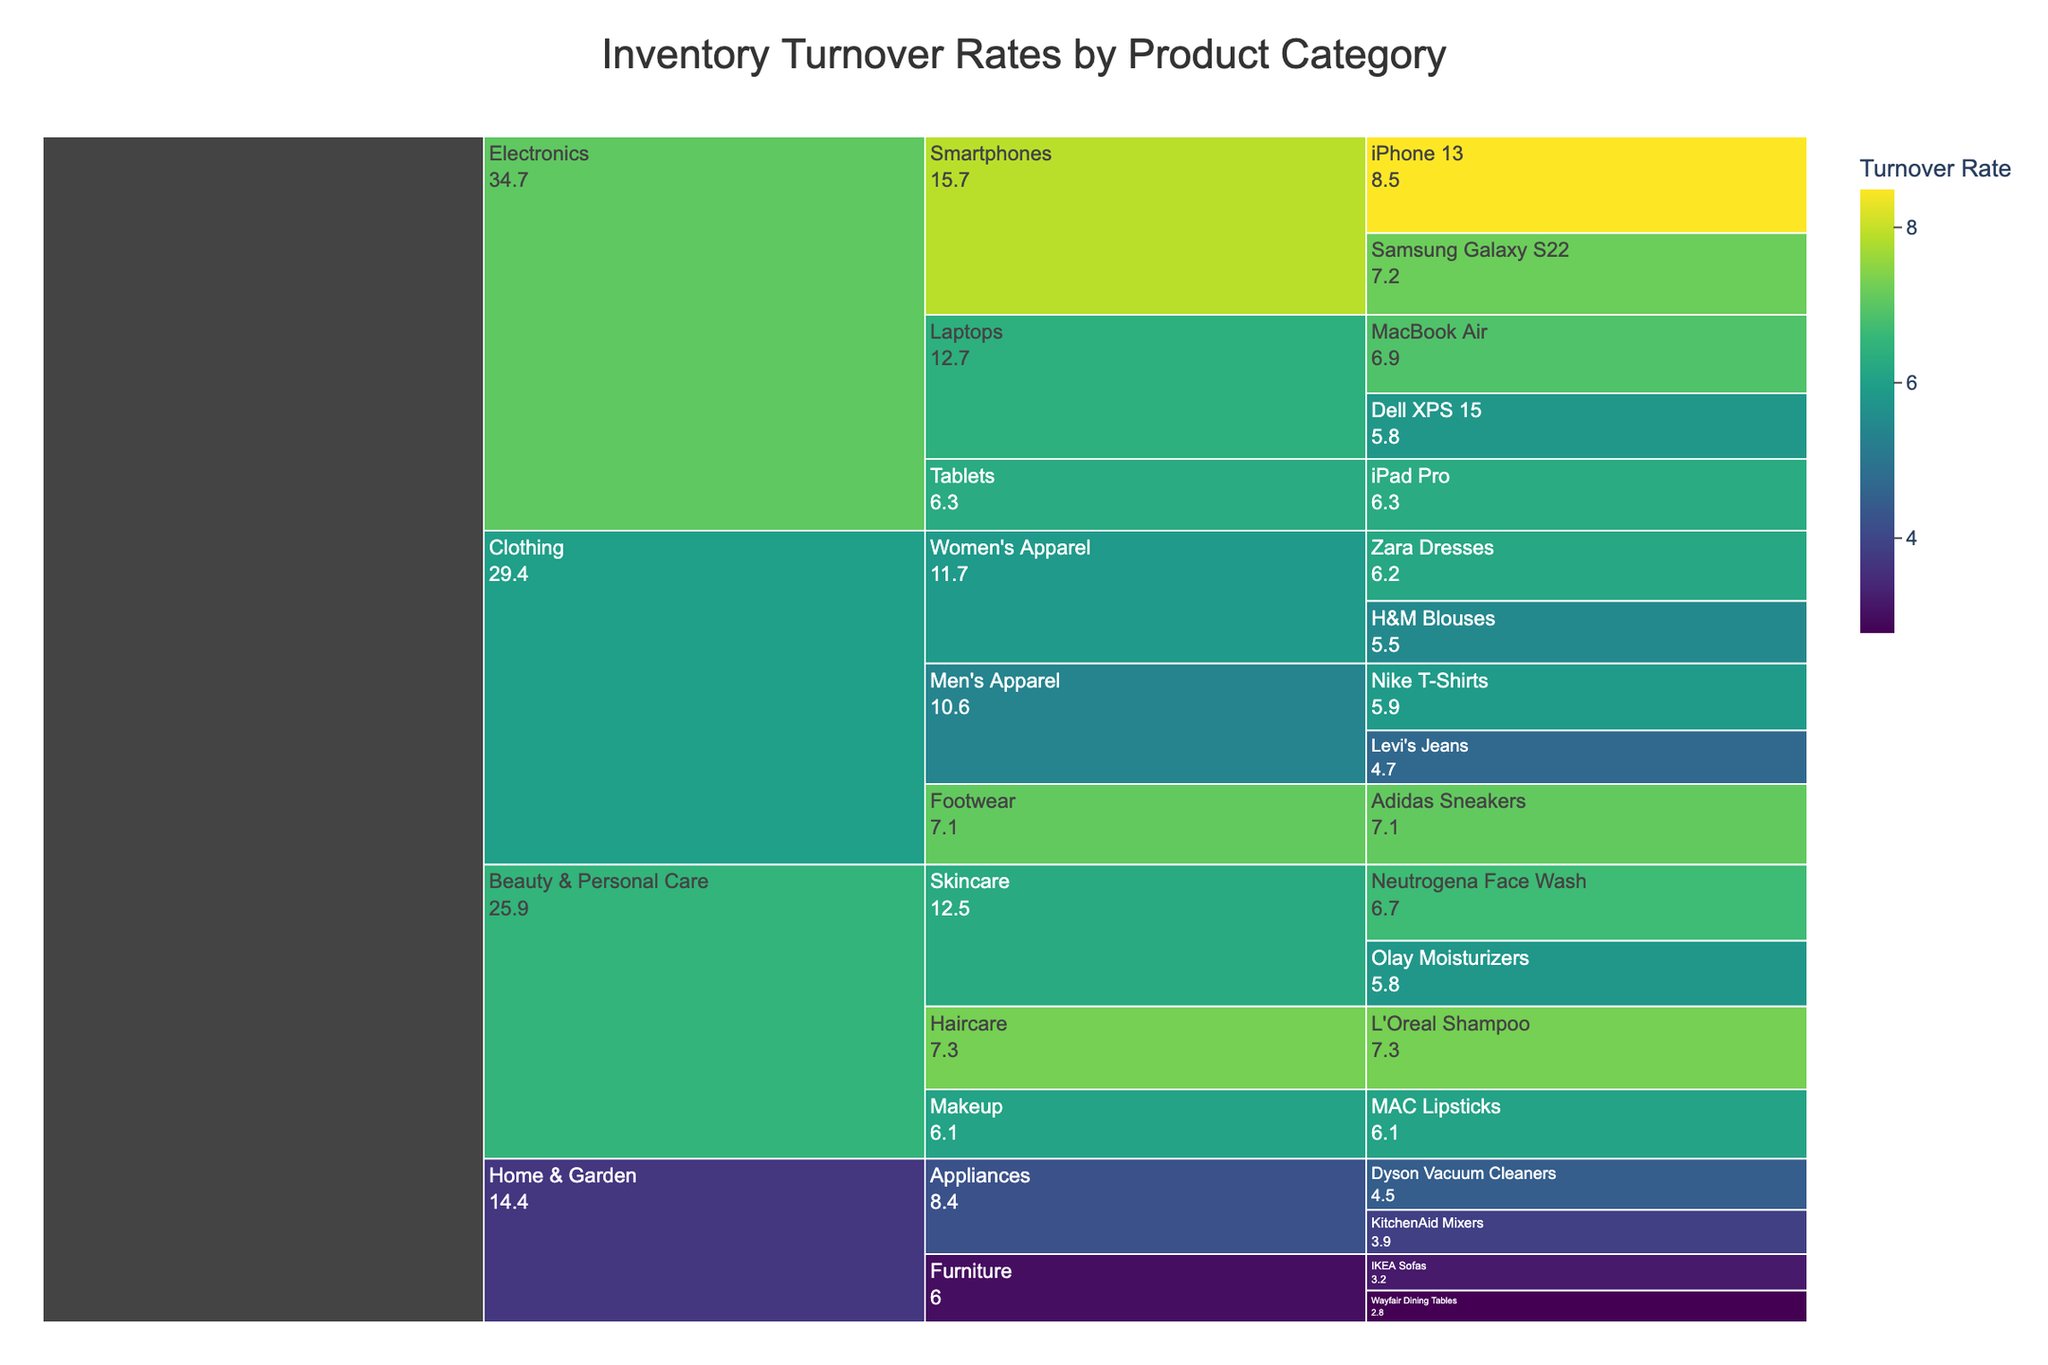What's the title of the icicle chart? The title of the icicle chart is mentioned at the top of the figure. Look for the large, bold text that stands out from the rest of the content.
Answer: Inventory Turnover Rates by Product Category Which product has the highest inventory turnover rate? The product with the highest inventory turnover rate has the highest value within its subcategory block. Scan through all the product blocks to find the highest value.
Answer: iPhone 13 What is the average inventory turnover rate for the Electronics category? First, identify all inventory turnover rates for products under the Electronics category: iPhone 13 (8.5), Samsung Galaxy S22 (7.2), Dell XPS 15 (5.8), MacBook Air (6.9), iPad Pro (6.3). Sum these values and divide by the number of products (5). Calculation: (8.5 + 7.2 + 5.8 + 6.9 + 6.3)/5 = 6.94.
Answer: 6.94 Which subcategory in the Clothing category has the highest average inventory turnover rate? Calculate the average turnover rates for each of the subcategories in the Clothing category. Men's Apparel: (4.7 + 5.9)/2 = 5.3. Women's Apparel: (6.2 + 5.5)/2 = 5.85. Footwear: (7.1) = 7.1. Compare the averages to determine the highest one.
Answer: Footwear How does the turnover rate of Neutrogena Face Wash compare to that of Olay Moisturizers? Locate both products under the Beauty & Personal Care category and compare their inventory turnover values. Neutrogena Face Wash has a turnover rate of 6.7, and Olay Moisturizers have a turnover rate of 5.8.
Answer: Neutrogena Face Wash is higher Which category has the product with the lowest inventory turnover rate? Identify the category containing the product with the lowest value among all product blocks. The lowest value is 2.8 for Wayfair Dining Tables in the Home & Garden category.
Answer: Home & Garden What is the difference between the inventory turnover rates of the highest and lowest products in the chart? Identify the highest and lowest inventory turnover rates: Highest (iPhone 13, 8.5), Lowest (Wayfair Dining Tables, 2.8). Calculate the difference: 8.5 - 2.8 = 5.7
Answer: 5.7 In the Home & Garden category, which subcategory has a higher total inventory turnover rate? Calculate the total turnover rate for each subcategory in Home & Garden. Furniture: (3.2 + 2.8) = 6.0. Appliances: (4.5 + 3.9) = 8.4. Compare the totals to determine which is higher.
Answer: Appliances Which product in the Beauty & Personal Care category has the highest inventory turnover rate? Identify the products in Beauty & Personal Care and compare their turnover rates: Neutrogena Face Wash (6.7), Olay Moisturizers (5.8), L'Oreal Shampoo (7.3), MAC Lipsticks (6.1). The highest rate is 7.3 for L'Oreal Shampoo.
Answer: L'Oreal Shampoo What can you infer about the inventory turnover rate distribution in the chart by color? The chart uses a color gradient (Viridis) to represent the turnover rates. Brighter colors indicate higher rates, while darker colors indicate lower rates. Observing the color distribution offers insights into how turnover rates vary across categories and subcategories.
Answer: Higher rates are brighter 